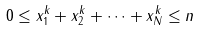<formula> <loc_0><loc_0><loc_500><loc_500>0 \leq x _ { 1 } ^ { k } + x _ { 2 } ^ { k } + \cdots + x _ { N } ^ { k } \leq n</formula> 